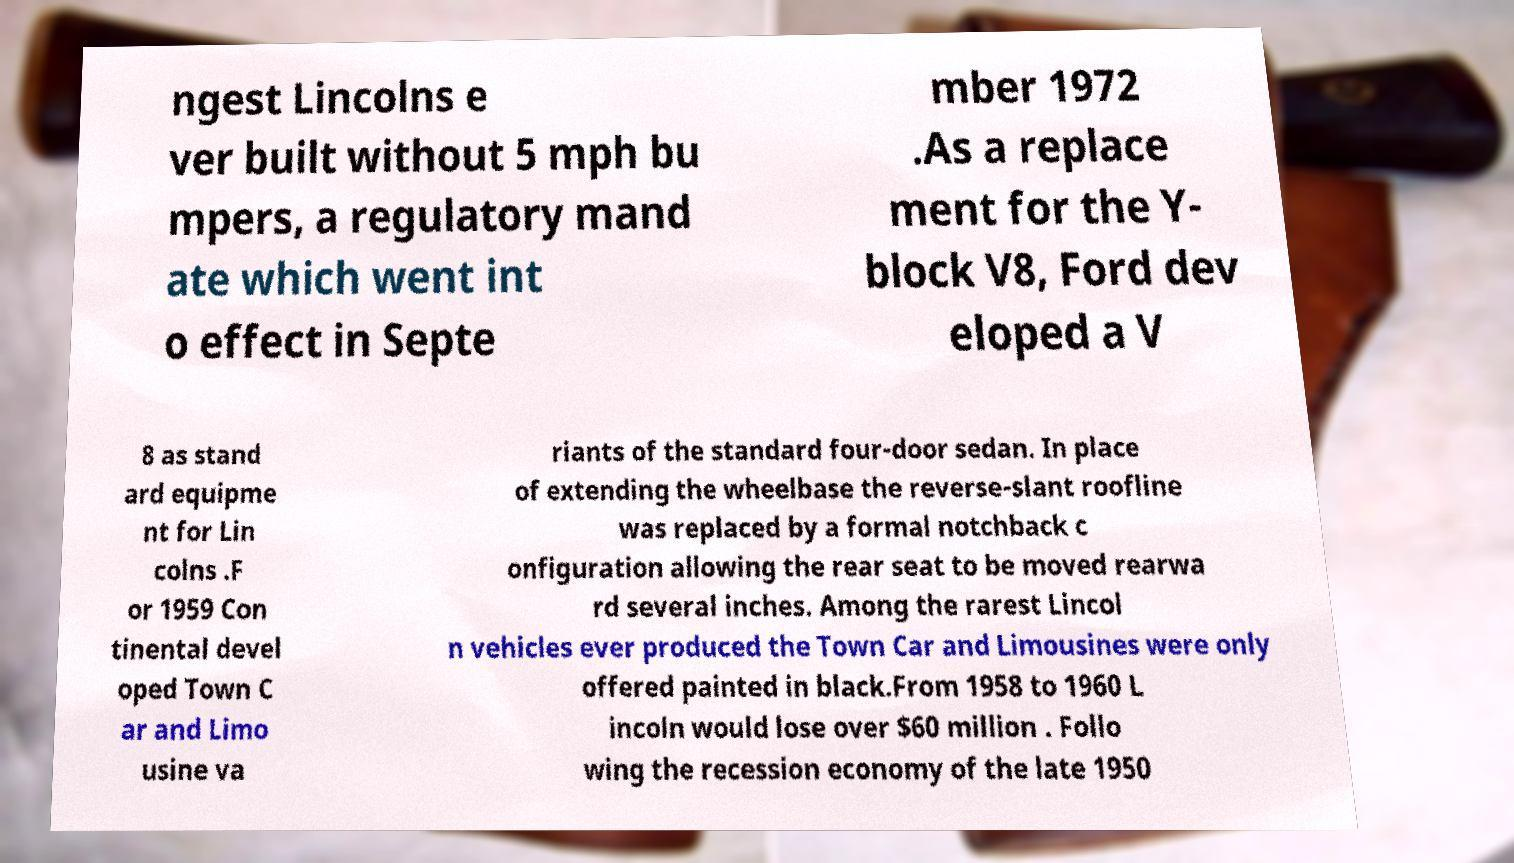Please identify and transcribe the text found in this image. ngest Lincolns e ver built without 5 mph bu mpers, a regulatory mand ate which went int o effect in Septe mber 1972 .As a replace ment for the Y- block V8, Ford dev eloped a V 8 as stand ard equipme nt for Lin colns .F or 1959 Con tinental devel oped Town C ar and Limo usine va riants of the standard four-door sedan. In place of extending the wheelbase the reverse-slant roofline was replaced by a formal notchback c onfiguration allowing the rear seat to be moved rearwa rd several inches. Among the rarest Lincol n vehicles ever produced the Town Car and Limousines were only offered painted in black.From 1958 to 1960 L incoln would lose over $60 million . Follo wing the recession economy of the late 1950 